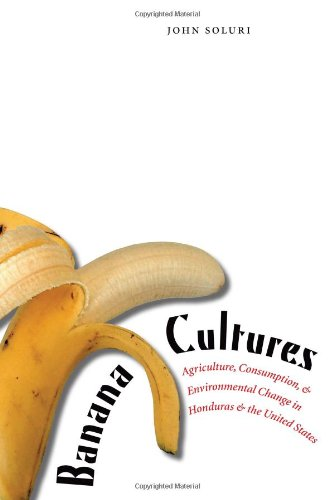What are some key historical events the book covers? The book covers key periods and events such as the rise of the banana industry in the early 20th century, labor movements in Honduras, and the impact of international policies and corporate practices. 